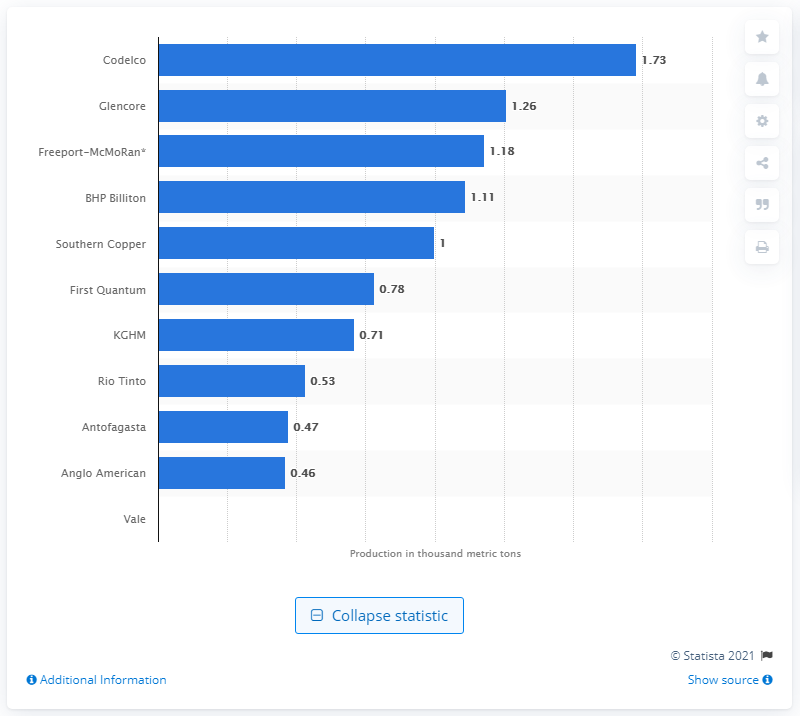Highlight a few significant elements in this photo. In 2020, Codelco was the copper mining company with the highest output. The second largest copper mining company in Chile was Glencore. 